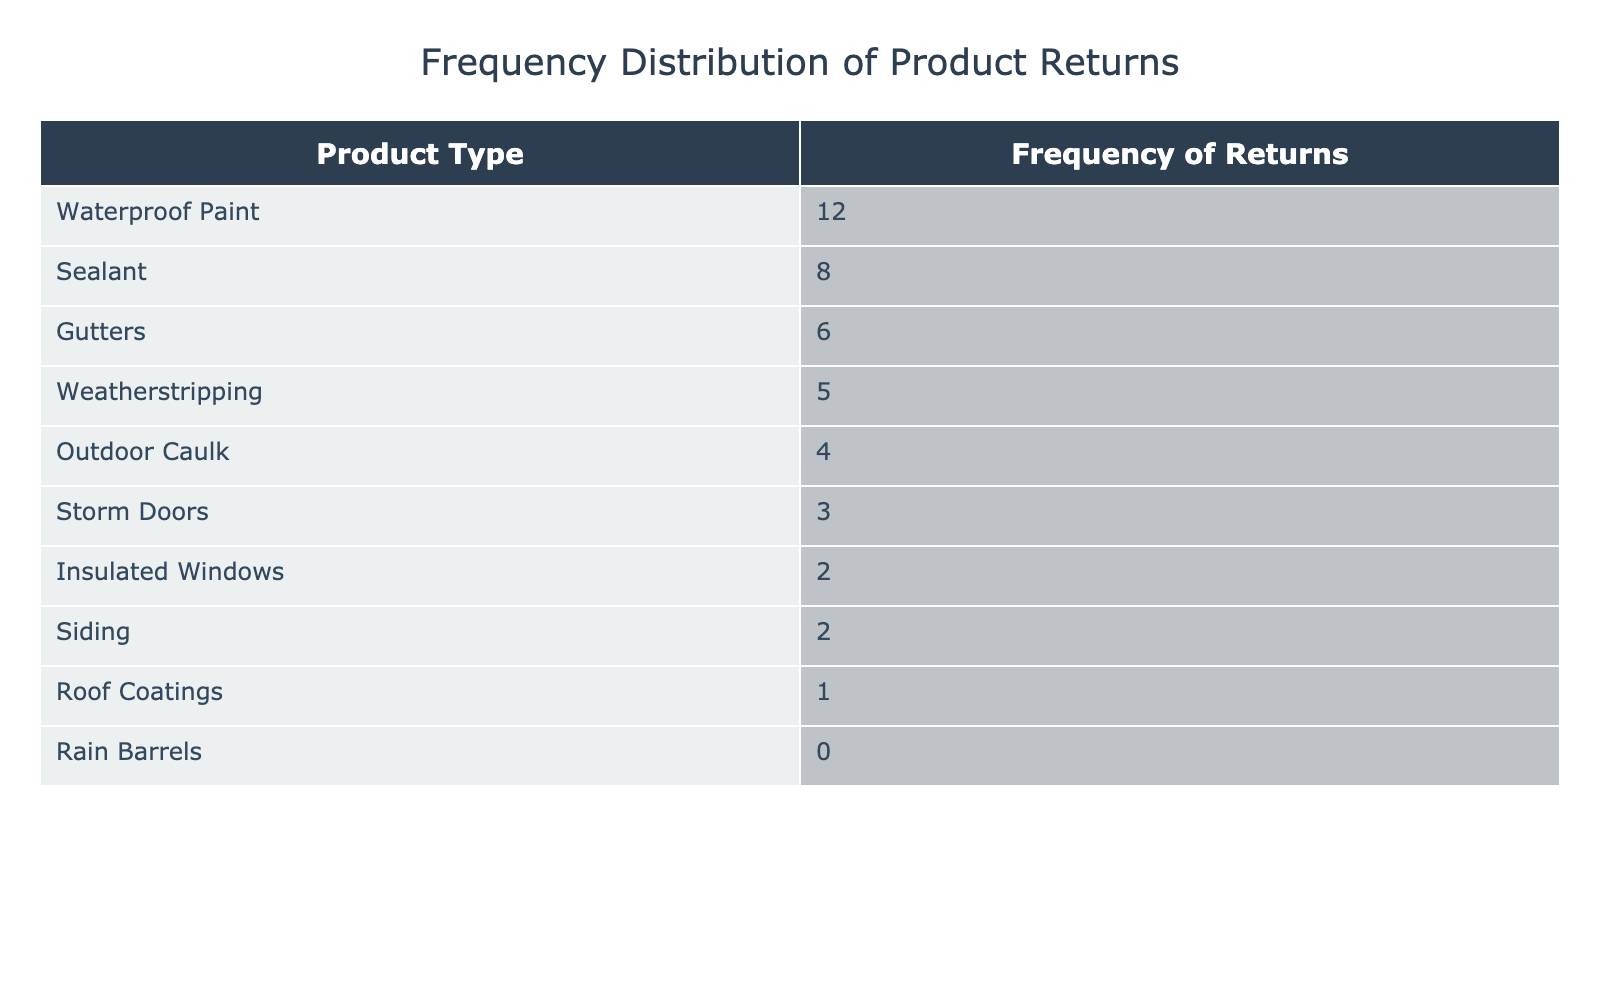What is the highest frequency of returns for a single product type? The highest frequency of returns is the value associated with the product type that has the most returns, which is "Waterproof Paint" with a frequency of 12.
Answer: 12 How many product types have a frequency of returns greater than 5? I can count the product types with frequencies greater than 5 directly from the table. They are: "Waterproof Paint" (12), "Sealant" (8), and "Gutters" (6). This makes a total of 3 product types.
Answer: 3 What is the total frequency of returns across all product types? To find the total frequency, I need to sum the frequencies of all product types: 12 + 8 + 5 + 4 + 3 + 2 + 1 + 0 + 6 + 2 = 41.
Answer: 41 Is the frequency of returns for "Rain Barrels" greater than that for "Insulated Windows"? I can compare the frequencies of the two products: "Rain Barrels" has a frequency of 0 while "Insulated Windows" has a frequency of 2. Since 0 is not greater than 2, the answer is no.
Answer: No What is the average frequency of returns for the top three product types with the most returns? The top three product types by frequency of returns are "Waterproof Paint" (12), "Sealant" (8), and "Gutters" (6). The average is calculated as (12 + 8 + 6) / 3 = 26 / 3 = approximately 8.67.
Answer: 8.67 Which product type has the least frequency of returns, and what is that frequency? Looking at the table, "Rain Barrels" has a frequency of 0 which is lower than all other product types. Therefore, the least frequency of returns is for "Rain Barrels."
Answer: Rain Barrels, 0 How many product types have a frequency of returns that is an even number? To determine this, I can list the even frequency numbers from the table: 12 (Waterproof Paint), 8 (Sealant), 4 (Outdoor Caulk), 2 (Insulated Windows), 0 (Rain Barrels), and 6 (Gutters). There are 6 product types.
Answer: 6 What is the difference in frequency of returns between "Waterproof Paint" and "Storm Doors"? I need to subtract the frequency of returns for "Storm Doors" (3) from the frequency for "Waterproof Paint" (12): 12 - 3 = 9.
Answer: 9 Are there more returned "Gutters" or "Storm Doors"? By checking the frequencies in the table, "Gutters" has a frequency of 6 and "Storm Doors" has a frequency of 3. Since 6 is greater than 3, yes, there are more returned "Gutters".
Answer: Yes 